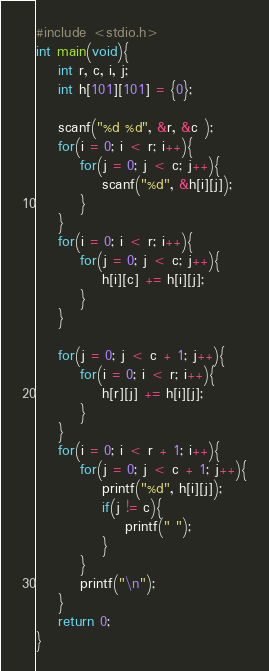Convert code to text. <code><loc_0><loc_0><loc_500><loc_500><_C_>#include <stdio.h>
int main(void){
    int r, c, i, j;
    int h[101][101] = {0};
     
    scanf("%d %d", &r, &c );
    for(i = 0; i < r; i++){
        for(j = 0; j < c; j++){
            scanf("%d", &h[i][j]);
        }
    }
    for(i = 0; i < r; i++){
        for(j = 0; j < c; j++){
            h[i][c] += h[i][j];
        }
    }
     
    for(j = 0; j < c + 1; j++){
        for(i = 0; i < r; i++){
            h[r][j] += h[i][j];
        }
    }
    for(i = 0; i < r + 1; i++){
        for(j = 0; j < c + 1; j++){
            printf("%d", h[i][j]);
            if(j != c){
                printf(" ");
            }
        }
        printf("\n");
    }
    return 0;
}
</code> 